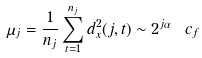Convert formula to latex. <formula><loc_0><loc_0><loc_500><loc_500>\mu _ { j } = \frac { 1 } { n _ { j } } \sum _ { t = 1 } ^ { n _ { j } } d _ { x } ^ { 2 } ( j , t ) \sim 2 ^ { j \alpha } \ c _ { f }</formula> 